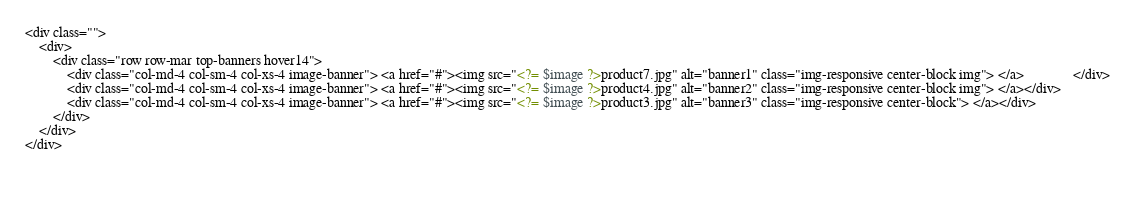Convert code to text. <code><loc_0><loc_0><loc_500><loc_500><_PHP_><div class="">
    <div>
        <div class="row row-mar top-banners hover14">
            <div class="col-md-4 col-sm-4 col-xs-4 image-banner"> <a href="#"><img src="<?= $image ?>product7.jpg" alt="banner1" class="img-responsive center-block img"> </a>              </div>
            <div class="col-md-4 col-sm-4 col-xs-4 image-banner"> <a href="#"><img src="<?= $image ?>product4.jpg" alt="banner2" class="img-responsive center-block img"> </a></div>
            <div class="col-md-4 col-sm-4 col-xs-4 image-banner"> <a href="#"><img src="<?= $image ?>product3.jpg" alt="banner3" class="img-responsive center-block"> </a></div>
        </div>
    </div>
</div>

 </code> 